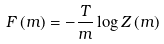<formula> <loc_0><loc_0><loc_500><loc_500>F \left ( m \right ) = - \frac { T } { m } \log Z \left ( m \right )</formula> 